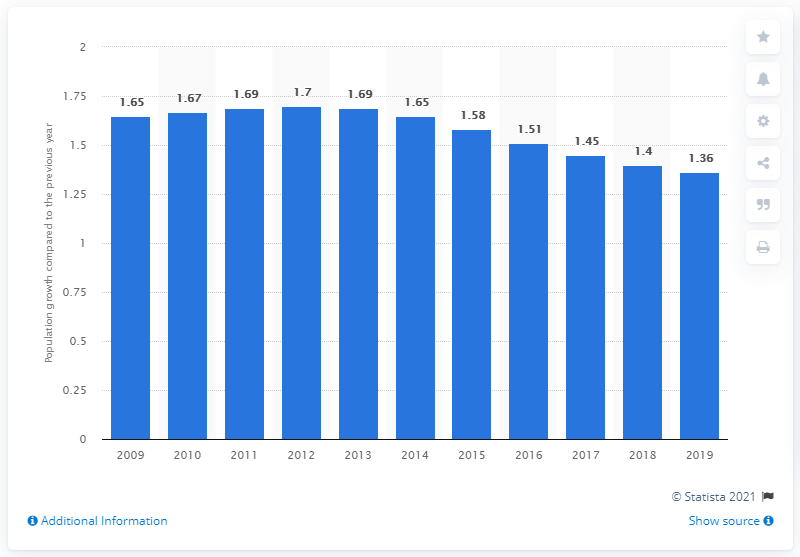Outline some significant characteristics in this image. The population of the Philippines in 2019 grew by 1.36%. 